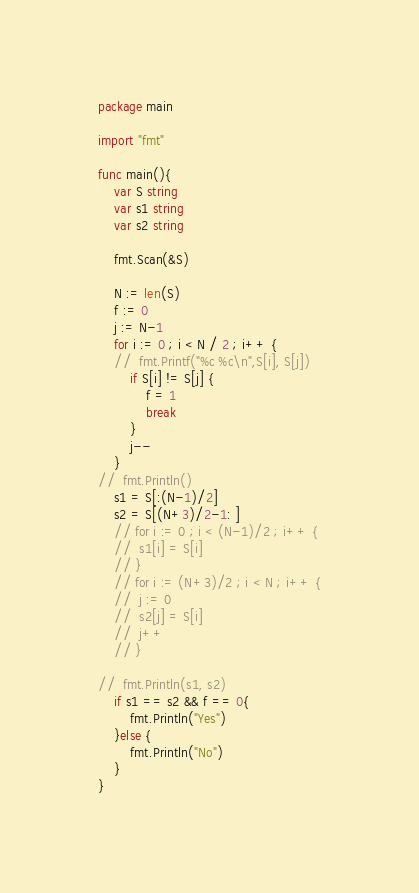<code> <loc_0><loc_0><loc_500><loc_500><_Go_>package main

import "fmt"

func main(){
	var S string
	var s1 string
	var s2 string

	fmt.Scan(&S)

	N := len(S)
	f := 0
	j := N-1
	for i := 0 ; i < N / 2 ; i++ {
	//	fmt.Printf("%c %c\n",S[i], S[j])
		if S[i] != S[j] {
			f = 1
			break	
		}
		j--
	}
//	fmt.Println()
	s1 = S[:(N-1)/2]
	s2 = S[(N+3)/2-1: ]
	// for i := 0 ; i < (N-1)/2 ; i++ {
	// 	s1[i] = S[i]
	// }
	// for i := (N+3)/2 ; i < N ; i++ {
	// 	j := 0
	// 	s2[j] = S[i]
	// 	j++
	// }
	
//	fmt.Println(s1, s2)
	if s1 == s2 && f == 0{
		fmt.Println("Yes")
	}else {
		fmt.Println("No")
	}
}</code> 